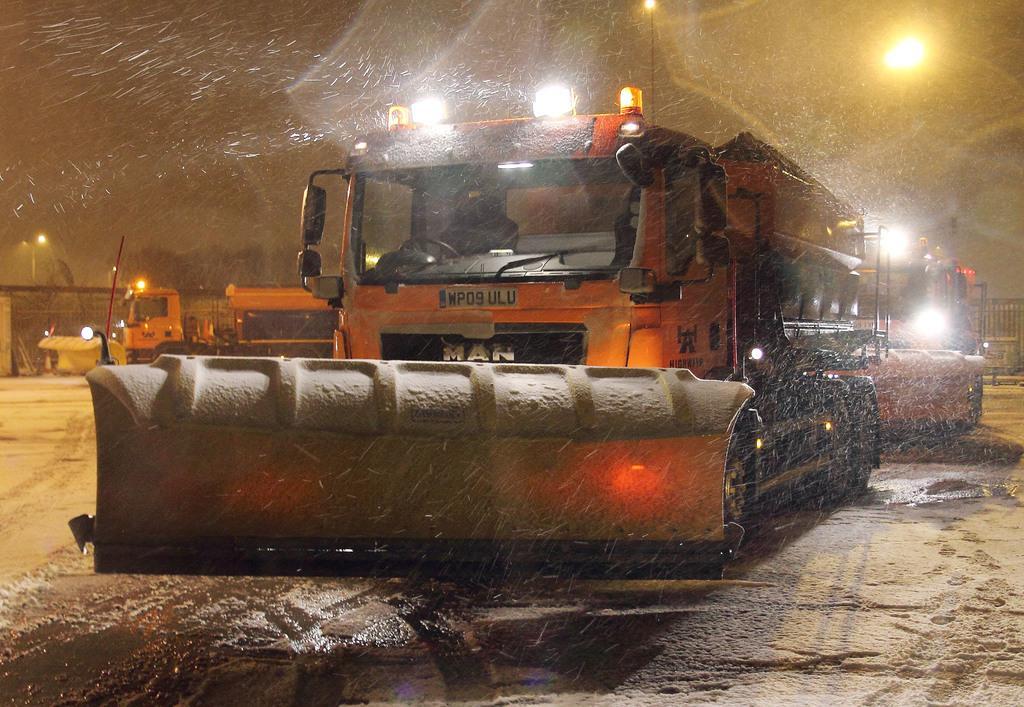Could you give a brief overview of what you see in this image? This image is taken during the night time. In this image we can see the vehicles. We can also see the water, sand, light poles and also the trees. Sky is also visible in this image. 